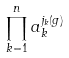Convert formula to latex. <formula><loc_0><loc_0><loc_500><loc_500>\prod _ { k = 1 } ^ { n } a _ { k } ^ { j _ { k } ( g ) }</formula> 